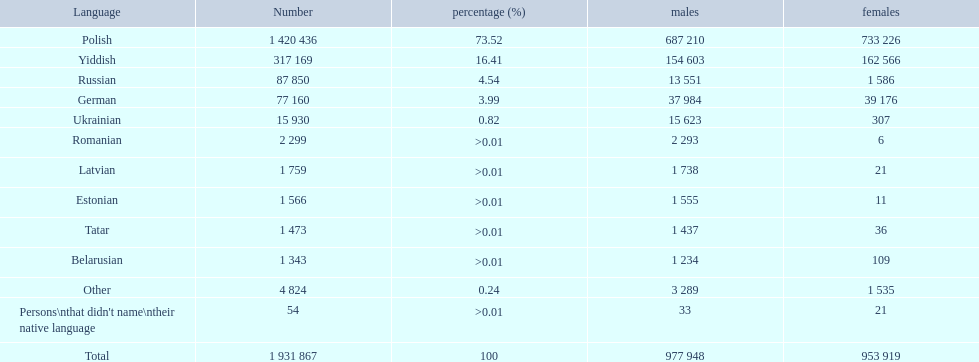What are all the spoken languages? Polish, Yiddish, Russian, German, Ukrainian, Romanian, Latvian, Estonian, Tatar, Belarusian. Which one of these has the most people speaking it? Polish. 